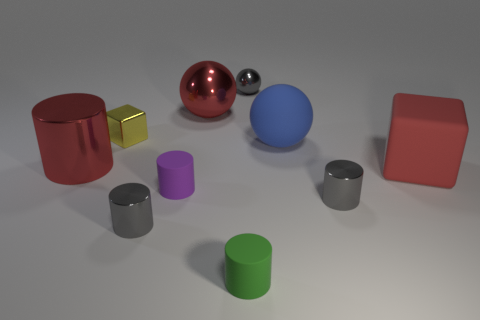Subtract all small spheres. How many spheres are left? 2 Add 9 matte cubes. How many matte cubes are left? 10 Add 3 green rubber cylinders. How many green rubber cylinders exist? 4 Subtract all blue balls. How many balls are left? 2 Subtract 0 brown cubes. How many objects are left? 10 Subtract all cubes. How many objects are left? 8 Subtract 2 spheres. How many spheres are left? 1 Subtract all red cylinders. Subtract all blue balls. How many cylinders are left? 4 Subtract all brown cylinders. How many purple spheres are left? 0 Subtract all tiny gray shiny balls. Subtract all small matte cylinders. How many objects are left? 7 